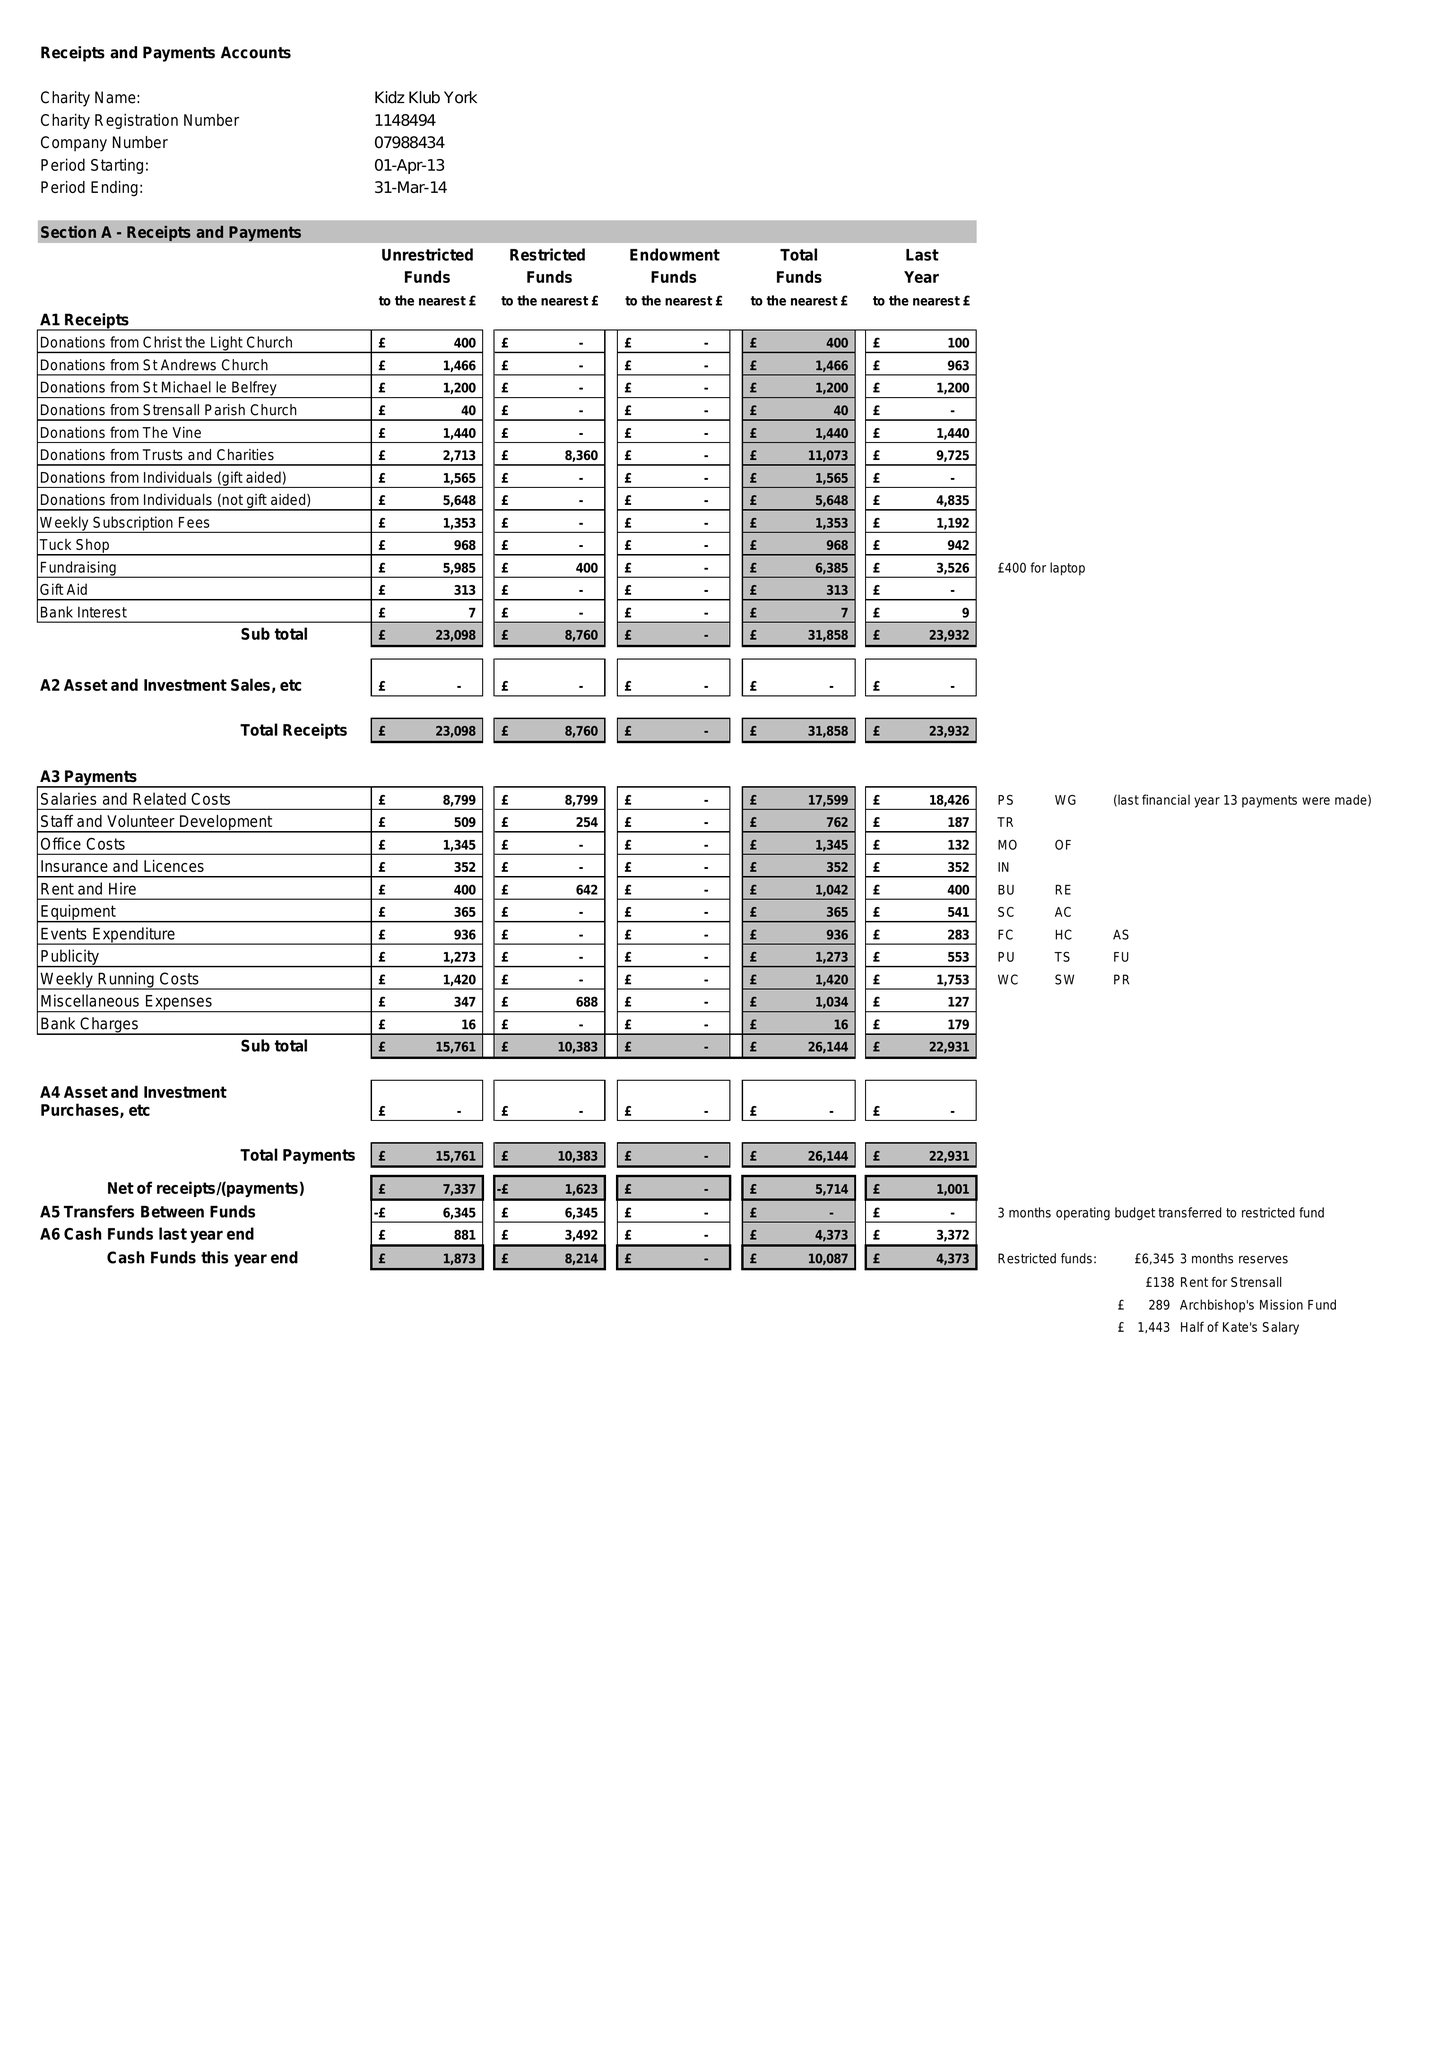What is the value for the income_annually_in_british_pounds?
Answer the question using a single word or phrase. 31858.00 